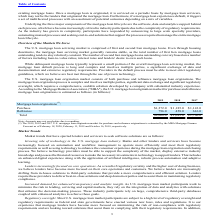According to Black Knight Financial Services's financial document, By whom was the U.S. mortgage loan origination market for purchase and refinance originations estimated by? MBA Mortgage Finance Forecast. The document states: "se and refinance originations is estimated by the MBA Mortgage Finance Forecast as of February 18, 2020, February 11, 2019 and October 16, 2018, respe..." Also, What was the mortgage loan originations for purchase originations in 2018? According to the financial document, 1,185.0 (in billions). The relevant text states: "tgage loan originations (1) : Purchase $1,272.0 $ 1,185.0 $ 1,143.0..." Also, Which years does the table provide information for the  U.S. mortgage loan origination market for purchase and refinance mortgage loan originations? The document contains multiple relevant values: 2019, 2018, 2017. From the document: "2019 2018 2017 2019 2018 2017 2019 2018 2017..." Also, can you calculate: What was the change in the refinance originations between 2017 and 2018? Based on the calculation: 458.0-616.0, the result is -158 (in billions). This is based on the information: "Refinance 796.0 458.0 616.0 Refinance 796.0 458.0 616.0..." The key data points involved are: 458.0, 616.0. Also, How many years did the purchase originations exceed $1,000 billion? Counting the relevant items in the document: 2019, 2018, 2017, I find 3 instances. The key data points involved are: 2017, 2018, 2019. Also, can you calculate: What was the percentage change in the total Mortgage loan originations between 2018 and 2019? To answer this question, I need to perform calculations using the financial data. The calculation is: (2,068.0-1,643.0)/1,643.0, which equals 25.87 (percentage). This is based on the information: "Total $2,068.0 $ 1,643.0 $ 1,760.0 Total $2,068.0 $ 1,643.0 $ 1,760.0..." The key data points involved are: 1,643.0, 2,068.0. 